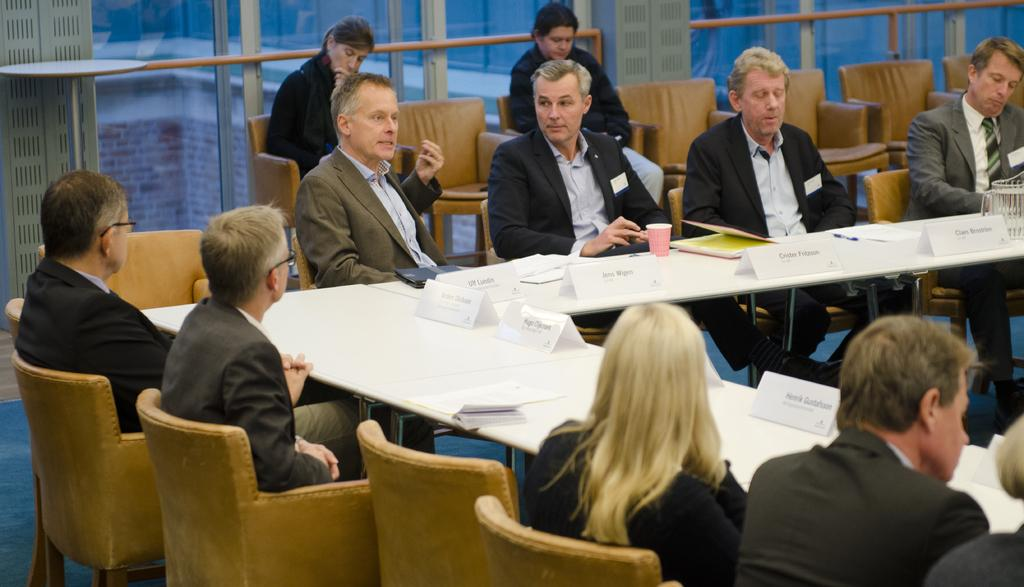What are the people in the image doing? The people in the image are sitting on chairs around a table. What can be seen on the table? There are name boards and a glass on the table. Can you describe the gender of the people in the image? There are both men and women in the picture. What type of flag is being waved by the person in the image? There is no flag present in the image; the people are sitting around a table with name boards and a glass. 